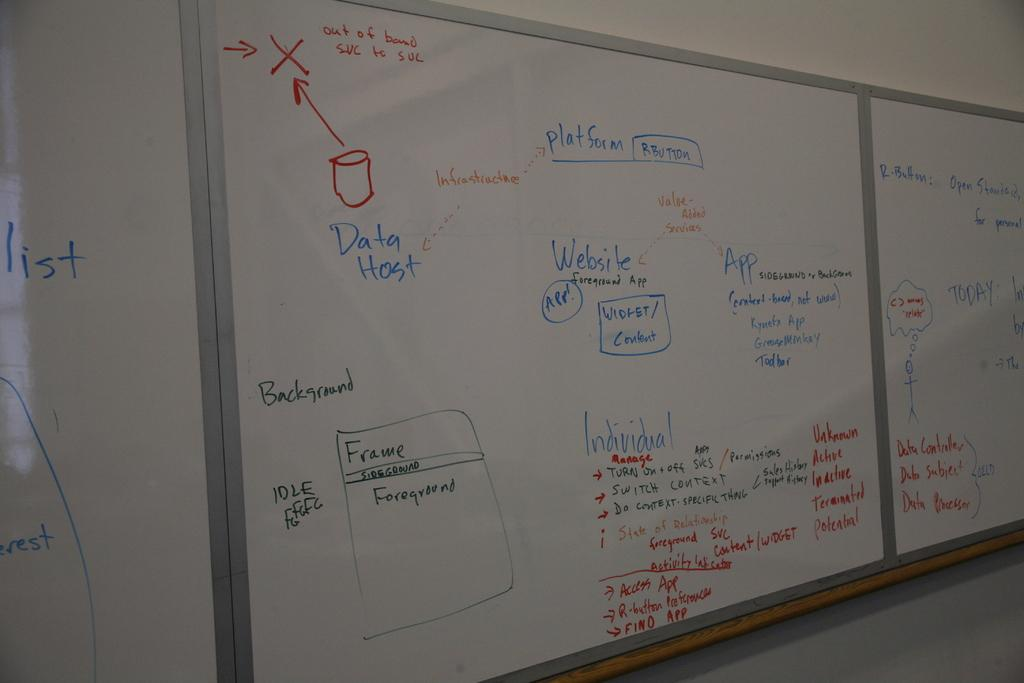<image>
Present a compact description of the photo's key features. A cylinder shape is drawn in red pointing to a red X on a dry erase, white board that has several different web ideas and suggestions written on it. 